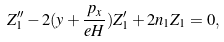<formula> <loc_0><loc_0><loc_500><loc_500>Z _ { 1 } ^ { \prime \prime } - 2 ( y + \frac { p _ { x } } { e H } ) Z ^ { \prime } _ { 1 } + 2 n _ { 1 } Z _ { 1 } = 0 ,</formula> 